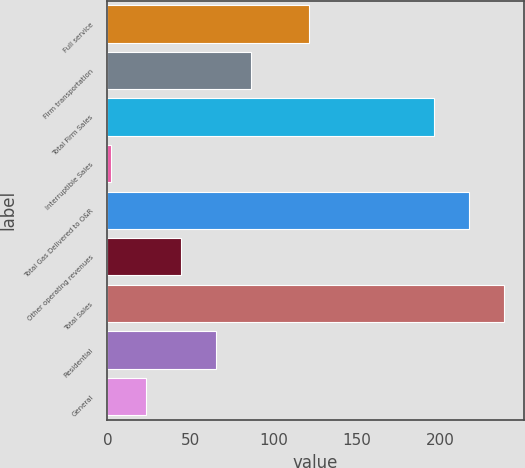Convert chart. <chart><loc_0><loc_0><loc_500><loc_500><bar_chart><fcel>Full service<fcel>Firm transportation<fcel>Total Firm Sales<fcel>Interruptible Sales<fcel>Total Gas Delivered to O&R<fcel>Other operating revenues<fcel>Total Sales<fcel>Residential<fcel>General<nl><fcel>121<fcel>86<fcel>196<fcel>2<fcel>217<fcel>44<fcel>238<fcel>65<fcel>23<nl></chart> 